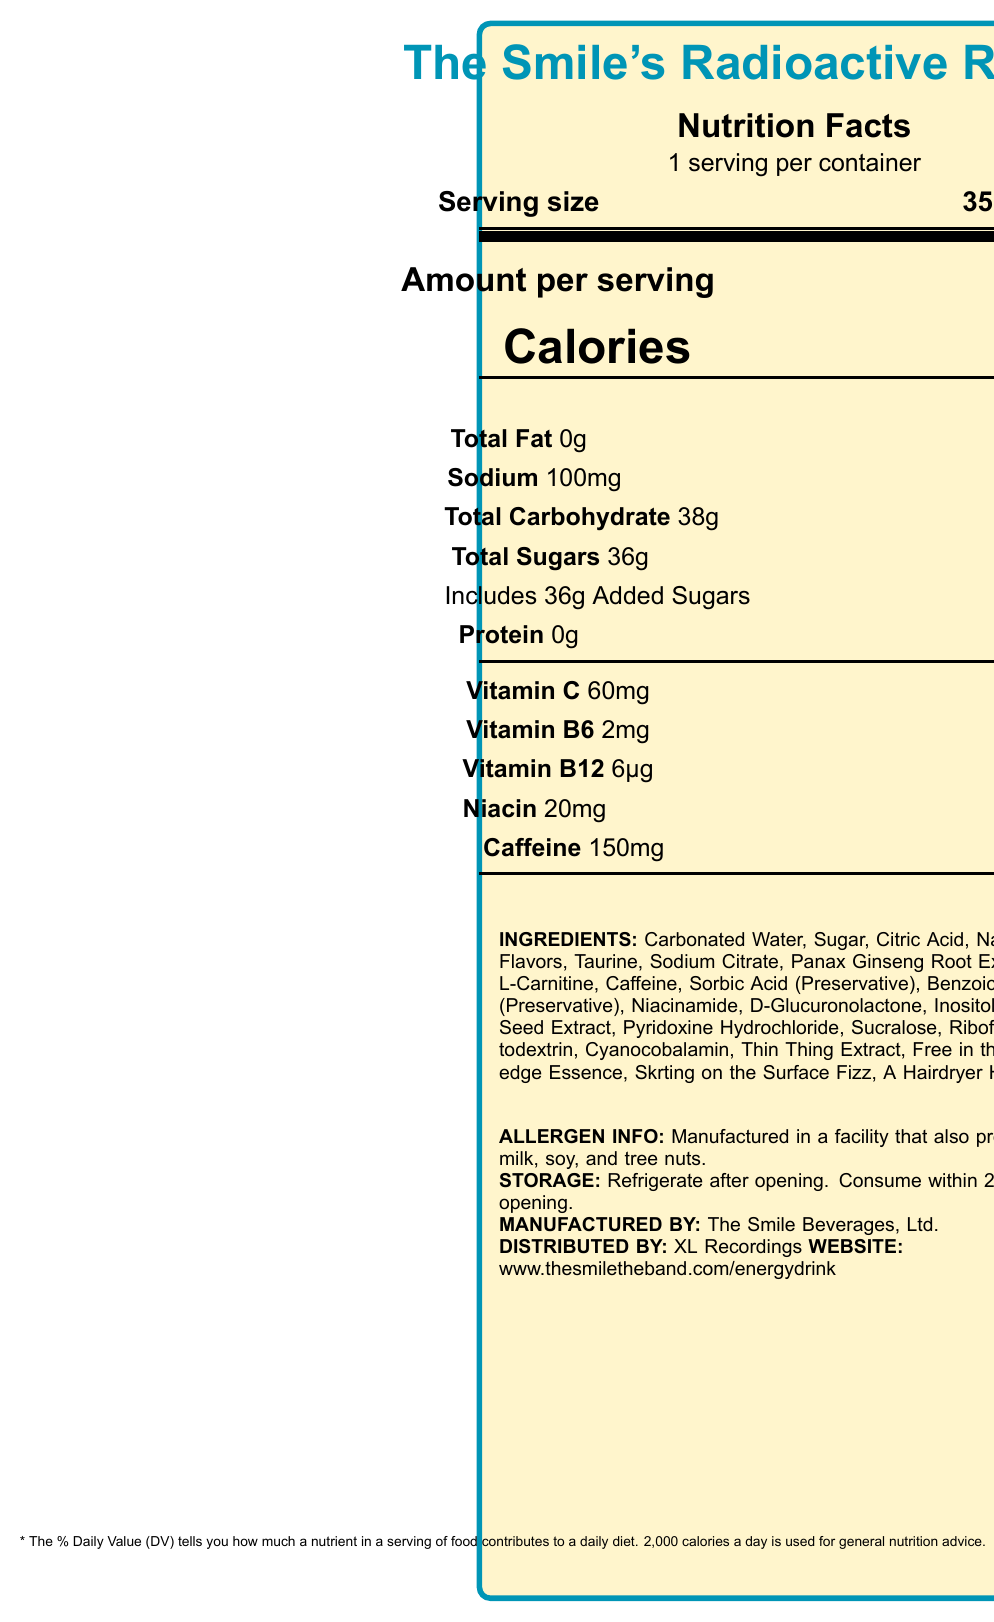what is the serving size of The Smile's Radioactive Refresher? The serving size is clearly stated as 355 mL (12 fl oz) on the label.
Answer: 355 mL (12 fl oz) how many calories are in one serving? The label specifies that there are 150 calories per serving.
Answer: 150 what amount of sodium is in a serving, and what percent of the daily value does this represent? The label shows that a serving contains 100mg of sodium, which is 4% of the daily value.
Answer: 100mg, 4% how much added sugars are in the drink, and what percent of the daily value is this? The label indicates that the drink contains 36g of added sugars, representing 72% of the daily value.
Answer: 36g, 72% what is the amount of caffeine per serving? The amount of caffeine per serving is listed as 150mg.
Answer: 150mg which vitamin is present in the highest daily value percentage? Vitamin B12 is present at 250% of the daily value, the highest percentage among the listed vitamins.
Answer: Vitamin B12 what are the lyrics-inspired ingredients in The Smile's Radioactive Refresher? The lyrics-inspired ingredients are stated as Thin Thing Extract, Free in the Knowledge Essence, Skrting on the Surface Fizz, and A Hairdryer Heat.
Answer: Thin Thing Extract, Free in the Knowledge Essence, Skrting on the Surface Fizz, A Hairdryer Heat who distributes The Smile's Radioactive Refresher? The label states that XL Recordings is the distributor.
Answer: XL Recordings how long should the drink be consumed after opening? The storage instructions specify that the drink should be consumed within 24 hours after opening.
Answer: Within 24 hours what is the main idea of this document? The document provides a comprehensive overview of the nutritional content, ingredients, and other relevant details for The Smile's Radioactive Refresher energy drink.
Answer: The Smile's Radioactive Refresher is a limited edition energy drink featuring lyrics-inspired ingredients, with detailed nutritional information and specific serving sizes. what is the total carbohydrate content in one serving? The label lists 38g as the total carbohydrate content per serving.
Answer: 38g what is the purpose of the *? The note at the bottom, marked with an asterisk (*), explains that the % Daily Value tells you how much a nutrient in a serving of food contributes to a daily diet, based on a 2,000 calorie diet.
Answer: To explain the daily value percentage note what is the amount of vitamin C per serving? The label indicates that each serving contains 60mg of vitamin C.
Answer: 60mg which of the following ingredients is not in The Smile's Radioactive Refresher? A. Carbonated Water B. Sugar C. High Fructose Corn Syrup D. Citric Acid High Fructose Corn Syrup is not listed among the ingredients.
Answer: C. High Fructose Corn Syrup how are allergens handled in the production of this drink? The allergen information states that the product is manufactured in a facility that also processes milk, soy, and tree nuts.
Answer: Manufactured in a facility that also processes milk, soy, and tree nuts what percentage of the daily value for niacin does one serving of the drink provide? The label shows that one serving provides 125% of the daily value for niacin.
Answer: 125% what is the distribution and manufacturing company for this drink? The manufacturer is The Smile Beverages, Ltd., and the distributor is XL Recordings.
Answer: XL Recordings distributes it, and The Smile Beverages, Ltd. manufactures it which ingredient contributes to the warming sensation in the drink? A. Citric Acid B. Ginger C. Caffeine D. Natural Flavors A Hairdryer Heat, which creates a warming sensation, is made from a blend of ginger and capsaicin.
Answer: B. Ginger can we determine the price of The Smile's Radioactive Refresher from the document? The document does not provide any pricing information for the drink.
Answer: Cannot be determined 